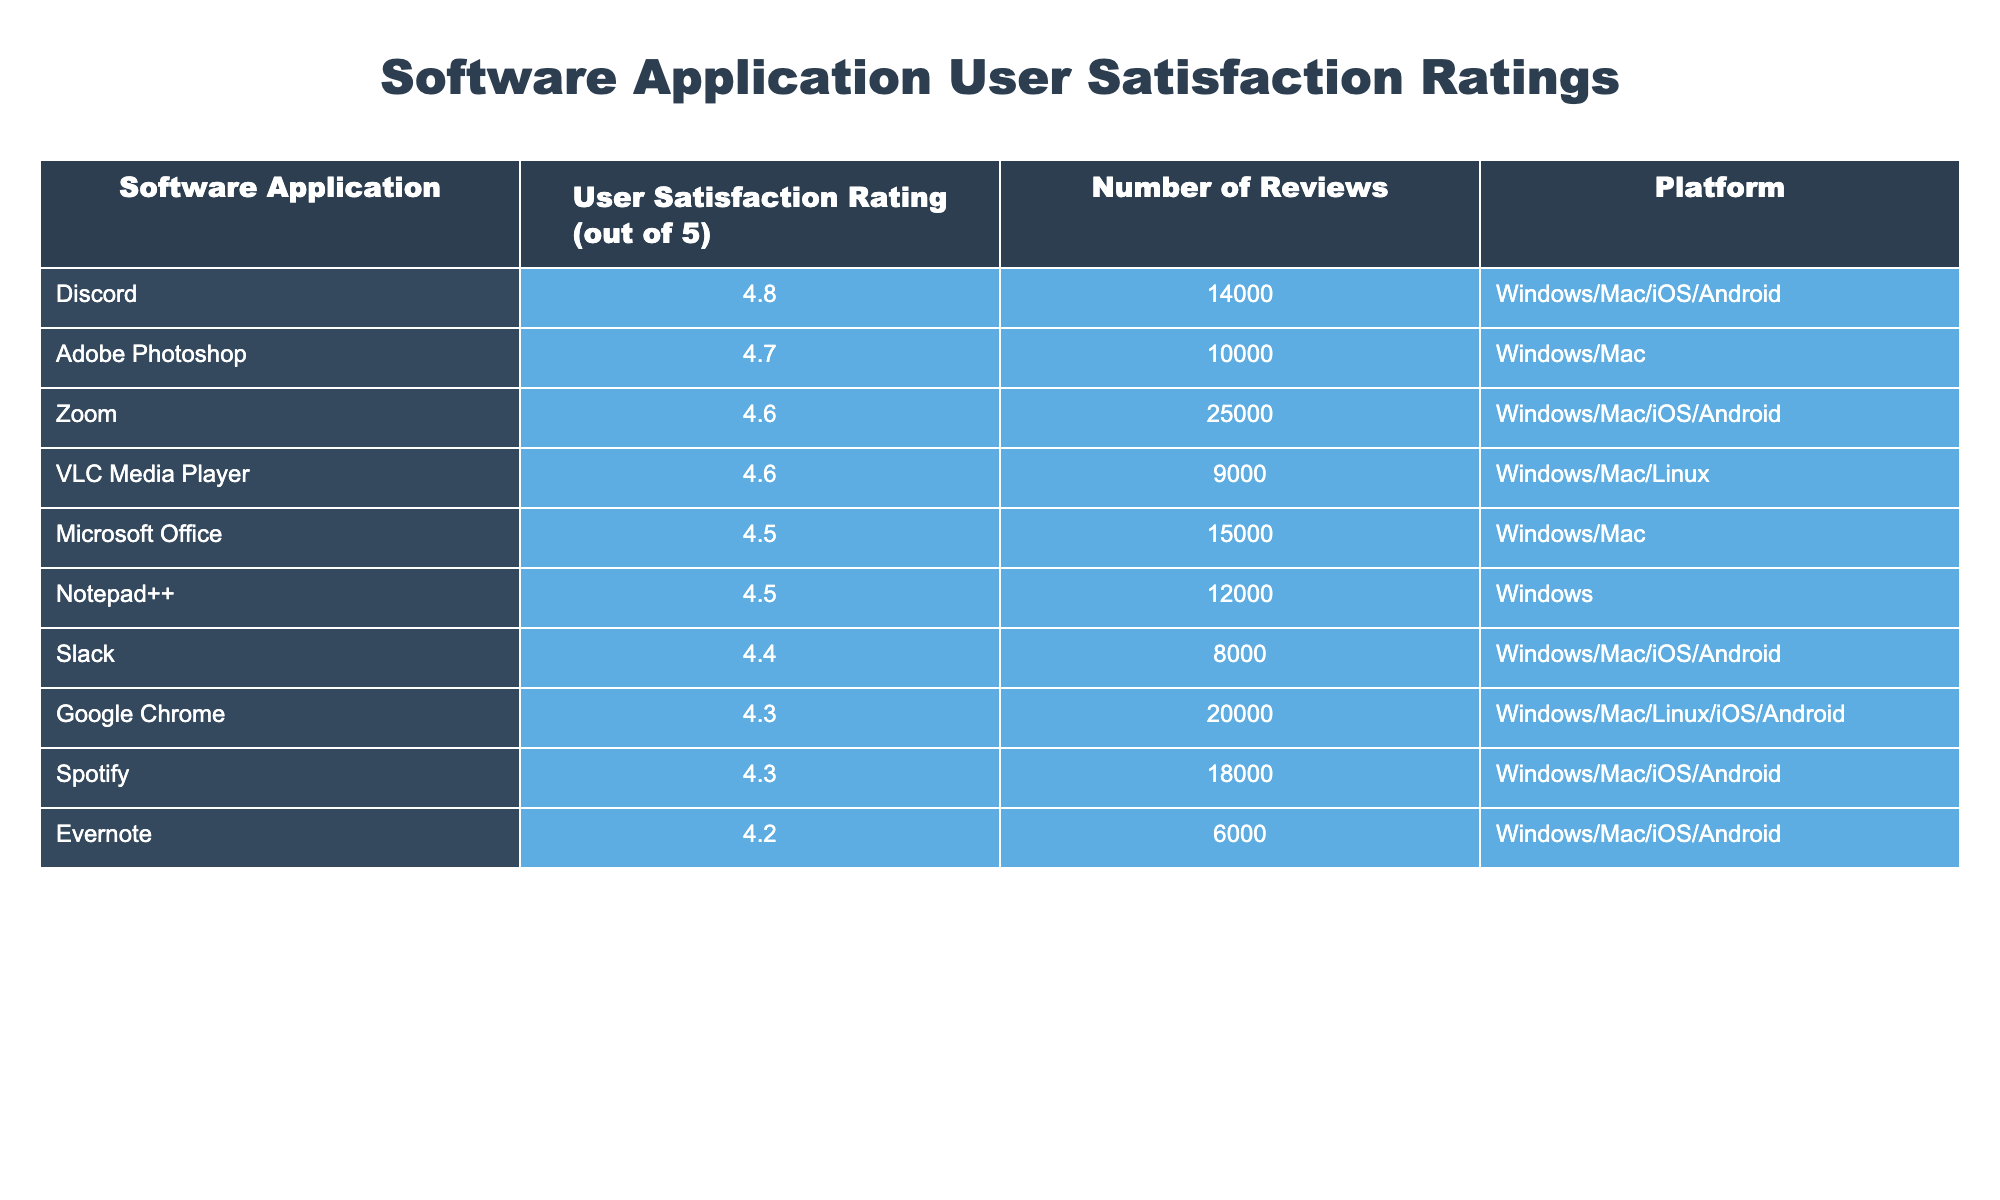What is the user satisfaction rating for Adobe Photoshop? The table lists Adobe Photoshop with a user satisfaction rating of 4.7. This value is found in the second column of the row corresponding to Adobe Photoshop.
Answer: 4.7 Which software application has the highest user satisfaction rating? By examining the user satisfaction ratings in the table, Discord has the highest rating at 4.8, which can be seen in the row for Discord.
Answer: Discord What is the total number of reviews for software applications with ratings above 4.5? The software applications with ratings above 4.5 are Microsoft Office (15000), Adobe Photoshop (10000), Zoom (25000), and Discord (14000). Adding these gives us a total of 15000 + 10000 + 25000 + 14000 = 64000 reviews.
Answer: 64000 Is the user satisfaction rating for Google Chrome greater than or equal to 4.5? Google Chrome's rating is 4.3 as noted in the table. Since 4.3 is less than 4.5, the answer is no.
Answer: No What is the average user satisfaction rating for all listed software applications? To find the average rating, we sum the ratings of all applications: 4.5 + 4.7 + 4.6 + 4.4 + 4.3 + 4.5 + 4.8 + 4.3 + 4.6 + 4.2 = 46.3, then divide by the number of applications, which is 10, yielding an average of 46.3 / 10 = 4.63.
Answer: 4.63 How many software applications have a user satisfaction rating below 4.4? The applications with ratings below 4.4 are Google Chrome (4.3), Evernote (4.2), and Spotify (4.3). Counting these gives us a total of 3 applications.
Answer: 3 Which platform is used by the most number of highly-rated applications (4.5 and above)? The applications rated 4.5 and above are Microsoft Office, Adobe Photoshop, Zoom, Discord, and VLC Media Player. Examining the platforms, Windows/Mac is the common platform for Microsoft Office, Adobe Photoshop, Zoom, Discord, while VLC also uses Windows/Mac/Linux. So the most common platform is Windows/Mac.
Answer: Windows/Mac Does Slack have a higher user satisfaction rating than VLC Media Player? Slack has a rating of 4.4 while VLC Media Player has a rating of 4.6. Since 4.4 is less than 4.6, Slack does not have a higher rating than VLC.
Answer: No What is the difference in user satisfaction ratings between the highest and lowest rated applications? The highest-rated application is Discord with a rating of 4.8 and the lowest-rated application is Evernote with a rating of 4.2. The difference is calculated as 4.8 - 4.2 = 0.6.
Answer: 0.6 